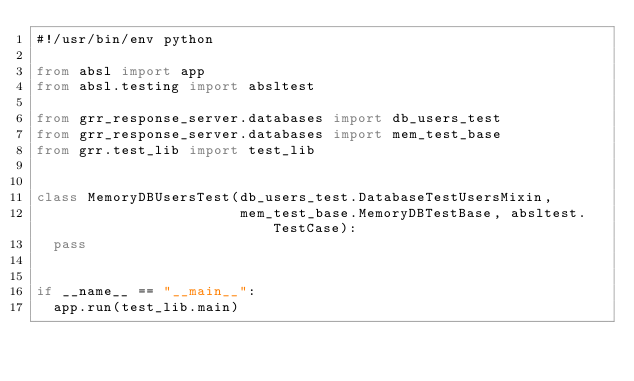Convert code to text. <code><loc_0><loc_0><loc_500><loc_500><_Python_>#!/usr/bin/env python

from absl import app
from absl.testing import absltest

from grr_response_server.databases import db_users_test
from grr_response_server.databases import mem_test_base
from grr.test_lib import test_lib


class MemoryDBUsersTest(db_users_test.DatabaseTestUsersMixin,
                        mem_test_base.MemoryDBTestBase, absltest.TestCase):
  pass


if __name__ == "__main__":
  app.run(test_lib.main)
</code> 